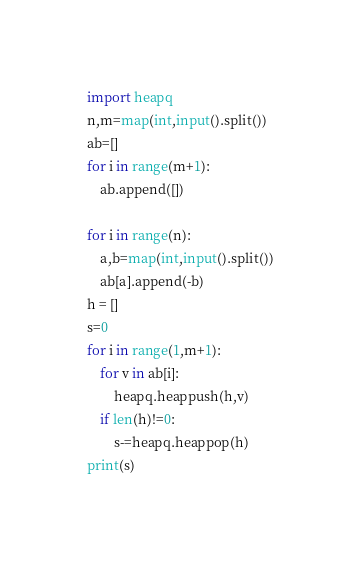<code> <loc_0><loc_0><loc_500><loc_500><_Python_>import heapq
n,m=map(int,input().split())
ab=[]
for i in range(m+1):
    ab.append([])
    
for i in range(n):
    a,b=map(int,input().split())
    ab[a].append(-b)
h = []
s=0
for i in range(1,m+1):
    for v in ab[i]:
        heapq.heappush(h,v)
    if len(h)!=0:
        s-=heapq.heappop(h)
print(s)</code> 